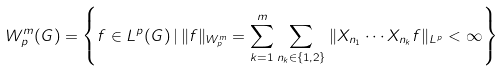Convert formula to latex. <formula><loc_0><loc_0><loc_500><loc_500>W ^ { m } _ { p } ( G ) = \left \{ f \in L ^ { p } ( G ) \, | \, \| f \| _ { W ^ { m } _ { p } } = \sum _ { k = 1 } ^ { m } \sum _ { n _ { k } \in \{ 1 , 2 \} } \| X _ { n _ { 1 } } \cdots X _ { n _ { k } } f \| _ { L ^ { p } } < \infty \right \}</formula> 